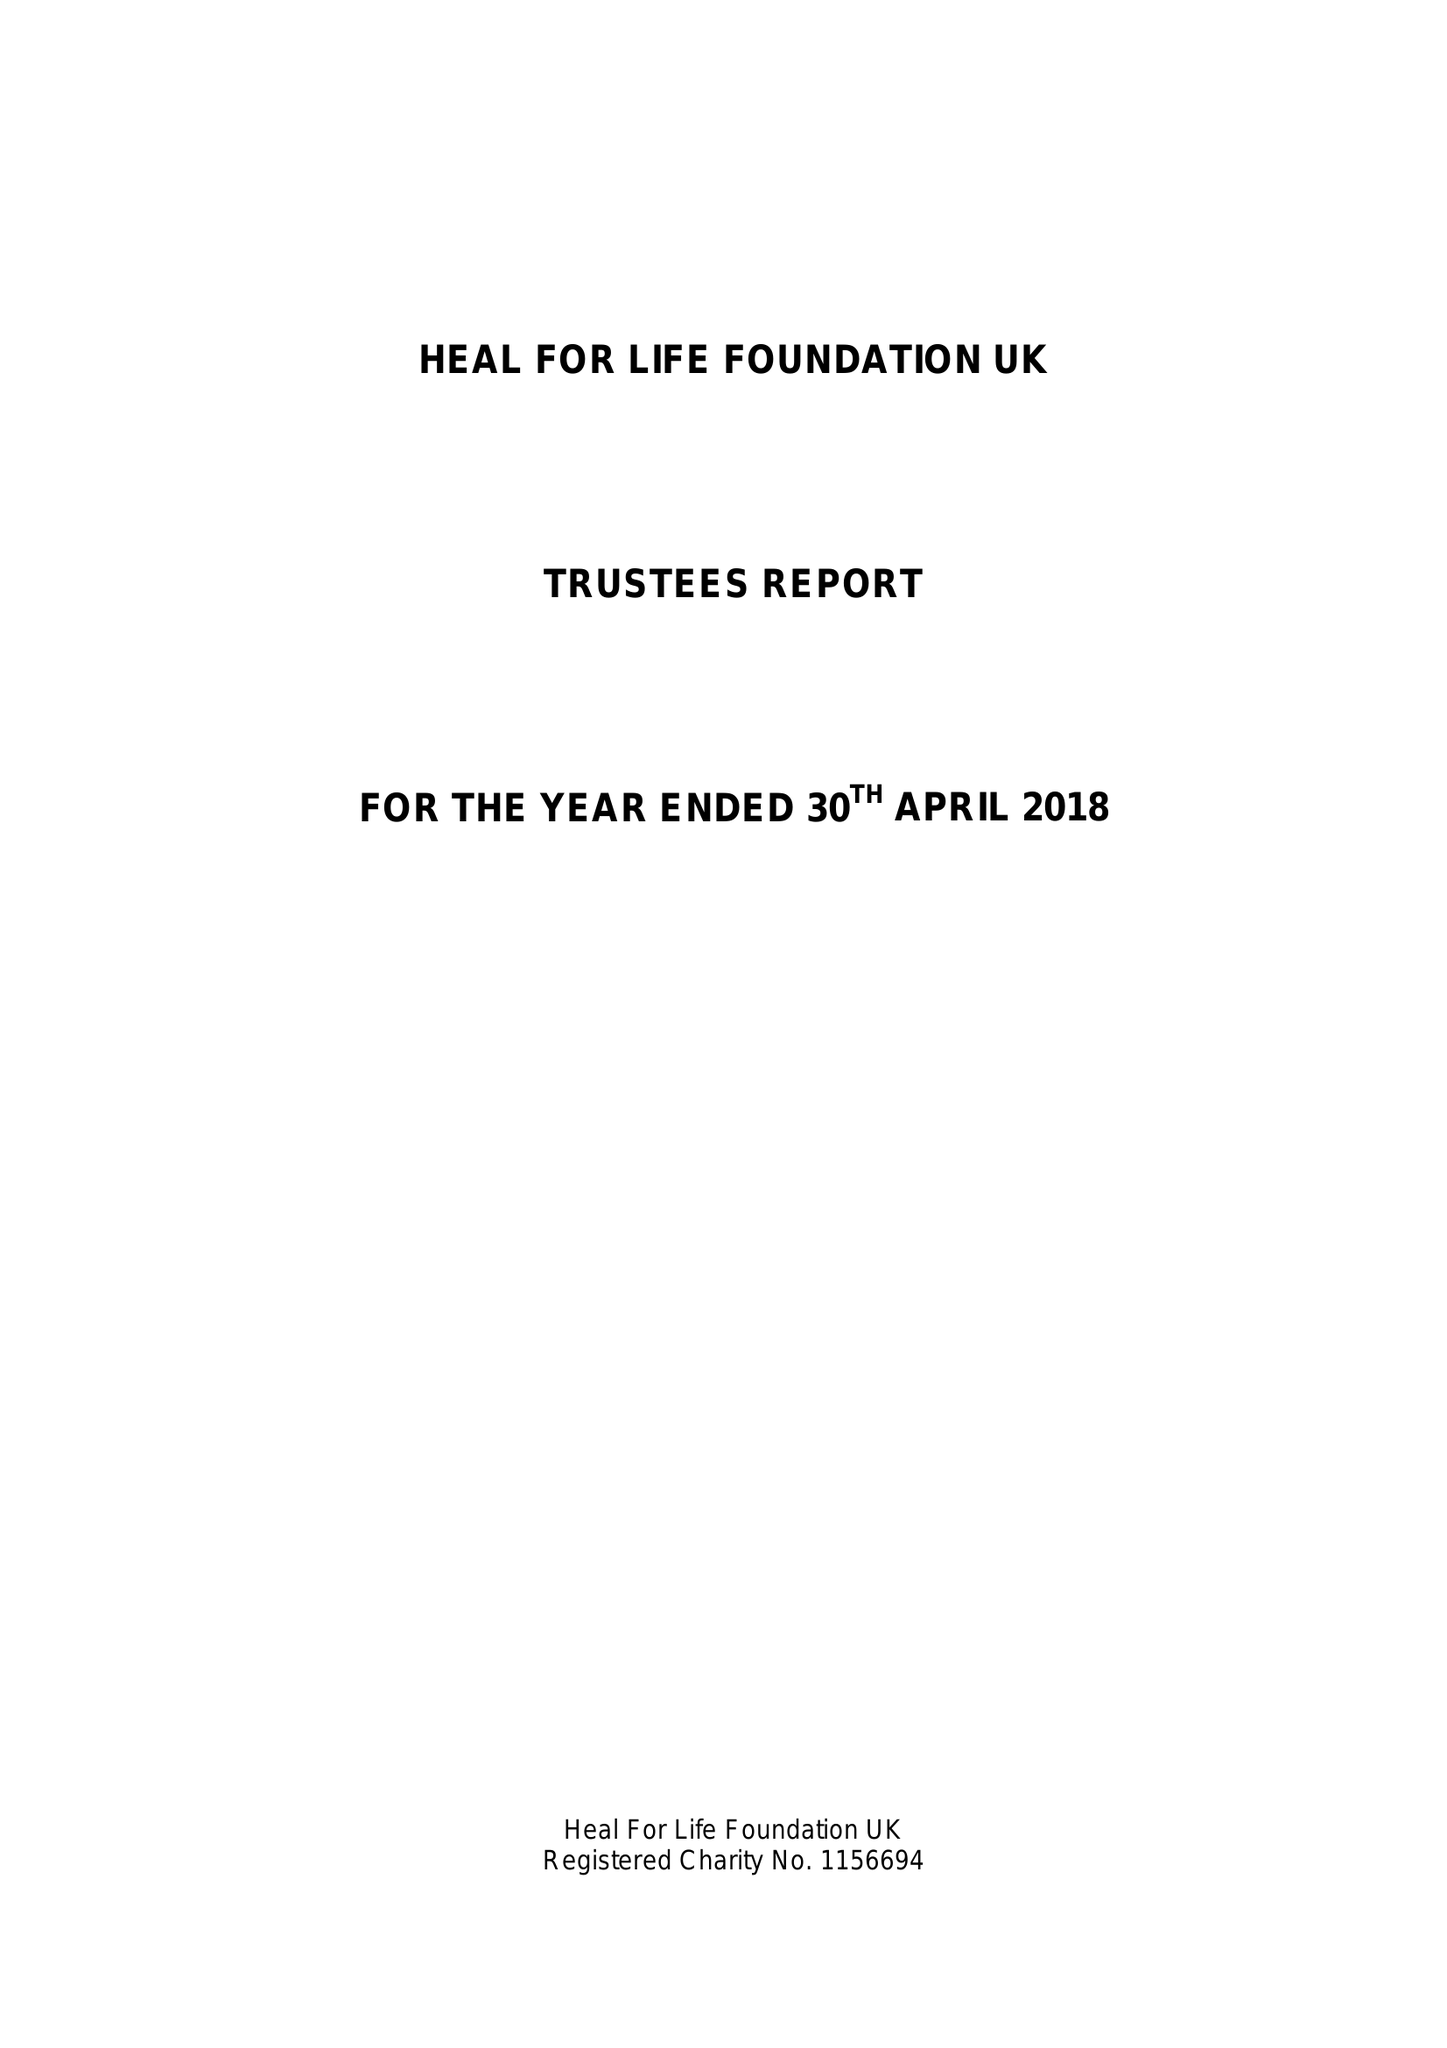What is the value for the address__post_town?
Answer the question using a single word or phrase. ASHFORD 